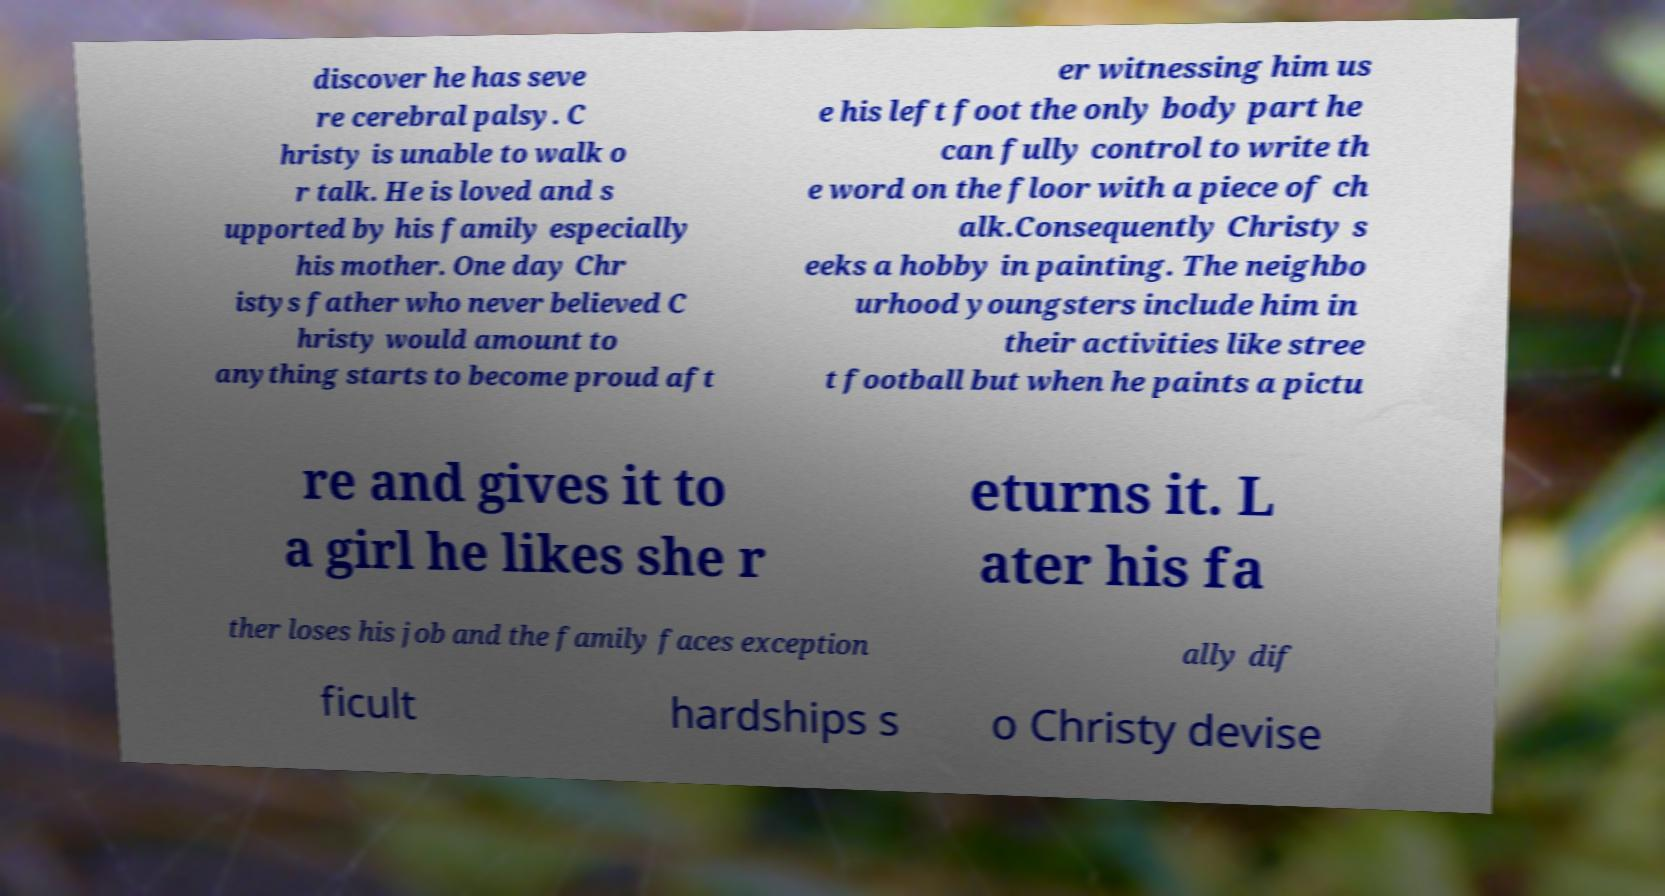Please identify and transcribe the text found in this image. discover he has seve re cerebral palsy. C hristy is unable to walk o r talk. He is loved and s upported by his family especially his mother. One day Chr istys father who never believed C hristy would amount to anything starts to become proud aft er witnessing him us e his left foot the only body part he can fully control to write th e word on the floor with a piece of ch alk.Consequently Christy s eeks a hobby in painting. The neighbo urhood youngsters include him in their activities like stree t football but when he paints a pictu re and gives it to a girl he likes she r eturns it. L ater his fa ther loses his job and the family faces exception ally dif ficult hardships s o Christy devise 